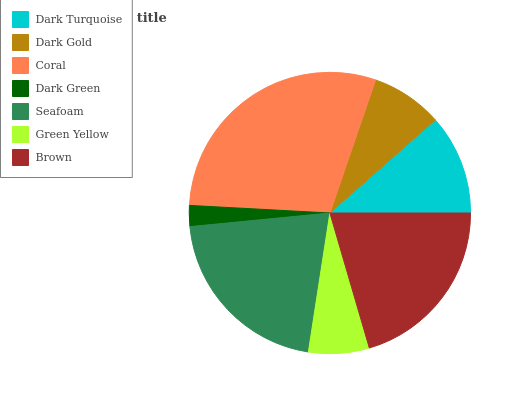Is Dark Green the minimum?
Answer yes or no. Yes. Is Coral the maximum?
Answer yes or no. Yes. Is Dark Gold the minimum?
Answer yes or no. No. Is Dark Gold the maximum?
Answer yes or no. No. Is Dark Turquoise greater than Dark Gold?
Answer yes or no. Yes. Is Dark Gold less than Dark Turquoise?
Answer yes or no. Yes. Is Dark Gold greater than Dark Turquoise?
Answer yes or no. No. Is Dark Turquoise less than Dark Gold?
Answer yes or no. No. Is Dark Turquoise the high median?
Answer yes or no. Yes. Is Dark Turquoise the low median?
Answer yes or no. Yes. Is Coral the high median?
Answer yes or no. No. Is Green Yellow the low median?
Answer yes or no. No. 